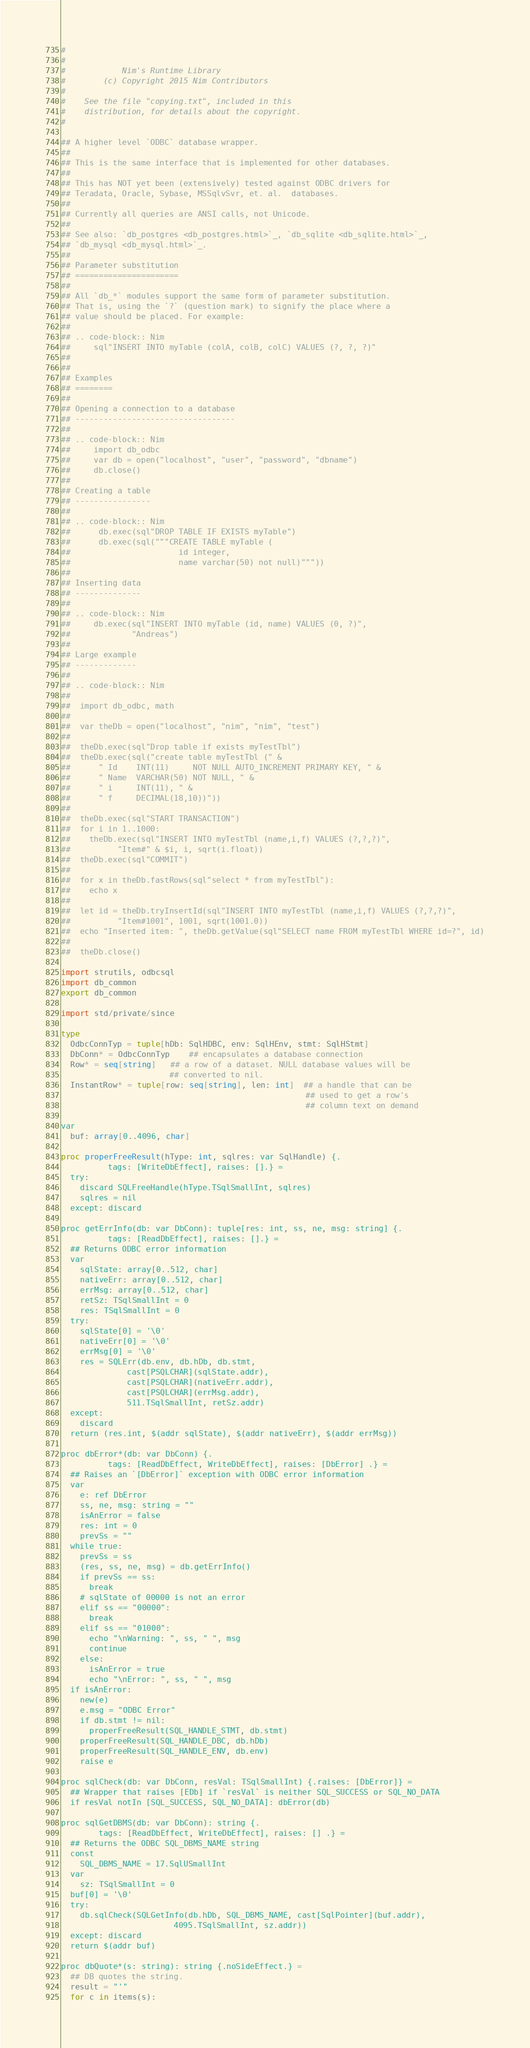<code> <loc_0><loc_0><loc_500><loc_500><_Nim_>#
#
#            Nim's Runtime Library
#        (c) Copyright 2015 Nim Contributors
#
#    See the file "copying.txt", included in this
#    distribution, for details about the copyright.
#

## A higher level `ODBC` database wrapper.
##
## This is the same interface that is implemented for other databases.
##
## This has NOT yet been (extensively) tested against ODBC drivers for
## Teradata, Oracle, Sybase, MSSqlvSvr, et. al.  databases.
##
## Currently all queries are ANSI calls, not Unicode.
##
## See also: `db_postgres <db_postgres.html>`_, `db_sqlite <db_sqlite.html>`_,
## `db_mysql <db_mysql.html>`_.
##
## Parameter substitution
## ======================
##
## All `db_*` modules support the same form of parameter substitution.
## That is, using the `?` (question mark) to signify the place where a
## value should be placed. For example:
##
## .. code-block:: Nim
##     sql"INSERT INTO myTable (colA, colB, colC) VALUES (?, ?, ?)"
##
##
## Examples
## ========
##
## Opening a connection to a database
## ----------------------------------
##
## .. code-block:: Nim
##     import db_odbc
##     var db = open("localhost", "user", "password", "dbname")
##     db.close()
##
## Creating a table
## ----------------
##
## .. code-block:: Nim
##      db.exec(sql"DROP TABLE IF EXISTS myTable")
##      db.exec(sql("""CREATE TABLE myTable (
##                       id integer,
##                       name varchar(50) not null)"""))
##
## Inserting data
## --------------
##
## .. code-block:: Nim
##     db.exec(sql"INSERT INTO myTable (id, name) VALUES (0, ?)",
##             "Andreas")
##
## Large example
## -------------
##
## .. code-block:: Nim
##
##  import db_odbc, math
##
##  var theDb = open("localhost", "nim", "nim", "test")
##
##  theDb.exec(sql"Drop table if exists myTestTbl")
##  theDb.exec(sql("create table myTestTbl (" &
##      " Id    INT(11)     NOT NULL AUTO_INCREMENT PRIMARY KEY, " &
##      " Name  VARCHAR(50) NOT NULL, " &
##      " i     INT(11), " &
##      " f     DECIMAL(18,10))"))
##
##  theDb.exec(sql"START TRANSACTION")
##  for i in 1..1000:
##    theDb.exec(sql"INSERT INTO myTestTbl (name,i,f) VALUES (?,?,?)",
##          "Item#" & $i, i, sqrt(i.float))
##  theDb.exec(sql"COMMIT")
##
##  for x in theDb.fastRows(sql"select * from myTestTbl"):
##    echo x
##
##  let id = theDb.tryInsertId(sql"INSERT INTO myTestTbl (name,i,f) VALUES (?,?,?)",
##          "Item#1001", 1001, sqrt(1001.0))
##  echo "Inserted item: ", theDb.getValue(sql"SELECT name FROM myTestTbl WHERE id=?", id)
##
##  theDb.close()

import strutils, odbcsql
import db_common
export db_common

import std/private/since

type
  OdbcConnTyp = tuple[hDb: SqlHDBC, env: SqlHEnv, stmt: SqlHStmt]
  DbConn* = OdbcConnTyp    ## encapsulates a database connection
  Row* = seq[string]   ## a row of a dataset. NULL database values will be
                       ## converted to nil.
  InstantRow* = tuple[row: seq[string], len: int]  ## a handle that can be
                                                    ## used to get a row's
                                                    ## column text on demand

var
  buf: array[0..4096, char]

proc properFreeResult(hType: int, sqlres: var SqlHandle) {.
          tags: [WriteDbEffect], raises: [].} =
  try:
    discard SQLFreeHandle(hType.TSqlSmallInt, sqlres)
    sqlres = nil
  except: discard

proc getErrInfo(db: var DbConn): tuple[res: int, ss, ne, msg: string] {.
          tags: [ReadDbEffect], raises: [].} =
  ## Returns ODBC error information
  var
    sqlState: array[0..512, char]
    nativeErr: array[0..512, char]
    errMsg: array[0..512, char]
    retSz: TSqlSmallInt = 0
    res: TSqlSmallInt = 0
  try:
    sqlState[0] = '\0'
    nativeErr[0] = '\0'
    errMsg[0] = '\0'
    res = SQLErr(db.env, db.hDb, db.stmt,
              cast[PSQLCHAR](sqlState.addr),
              cast[PSQLCHAR](nativeErr.addr),
              cast[PSQLCHAR](errMsg.addr),
              511.TSqlSmallInt, retSz.addr)
  except:
    discard
  return (res.int, $(addr sqlState), $(addr nativeErr), $(addr errMsg))

proc dbError*(db: var DbConn) {.
          tags: [ReadDbEffect, WriteDbEffect], raises: [DbError] .} =
  ## Raises an `[DbError]` exception with ODBC error information
  var
    e: ref DbError
    ss, ne, msg: string = ""
    isAnError = false
    res: int = 0
    prevSs = ""
  while true:
    prevSs = ss
    (res, ss, ne, msg) = db.getErrInfo()
    if prevSs == ss:
      break
    # sqlState of 00000 is not an error
    elif ss == "00000":
      break
    elif ss == "01000":
      echo "\nWarning: ", ss, " ", msg
      continue
    else:
      isAnError = true
      echo "\nError: ", ss, " ", msg
  if isAnError:
    new(e)
    e.msg = "ODBC Error"
    if db.stmt != nil:
      properFreeResult(SQL_HANDLE_STMT, db.stmt)
    properFreeResult(SQL_HANDLE_DBC, db.hDb)
    properFreeResult(SQL_HANDLE_ENV, db.env)
    raise e

proc sqlCheck(db: var DbConn, resVal: TSqlSmallInt) {.raises: [DbError]} =
  ## Wrapper that raises [EDb] if `resVal` is neither SQL_SUCCESS or SQL_NO_DATA
  if resVal notIn [SQL_SUCCESS, SQL_NO_DATA]: dbError(db)

proc sqlGetDBMS(db: var DbConn): string {.
        tags: [ReadDbEffect, WriteDbEffect], raises: [] .} =
  ## Returns the ODBC SQL_DBMS_NAME string
  const
    SQL_DBMS_NAME = 17.SqlUSmallInt
  var
    sz: TSqlSmallInt = 0
  buf[0] = '\0'
  try:
    db.sqlCheck(SQLGetInfo(db.hDb, SQL_DBMS_NAME, cast[SqlPointer](buf.addr),
                        4095.TSqlSmallInt, sz.addr))
  except: discard
  return $(addr buf)

proc dbQuote*(s: string): string {.noSideEffect.} =
  ## DB quotes the string.
  result = "'"
  for c in items(s):</code> 